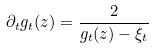Convert formula to latex. <formula><loc_0><loc_0><loc_500><loc_500>\partial _ { t } g _ { t } ( z ) = \frac { 2 } { g _ { t } ( z ) - \xi _ { t } }</formula> 